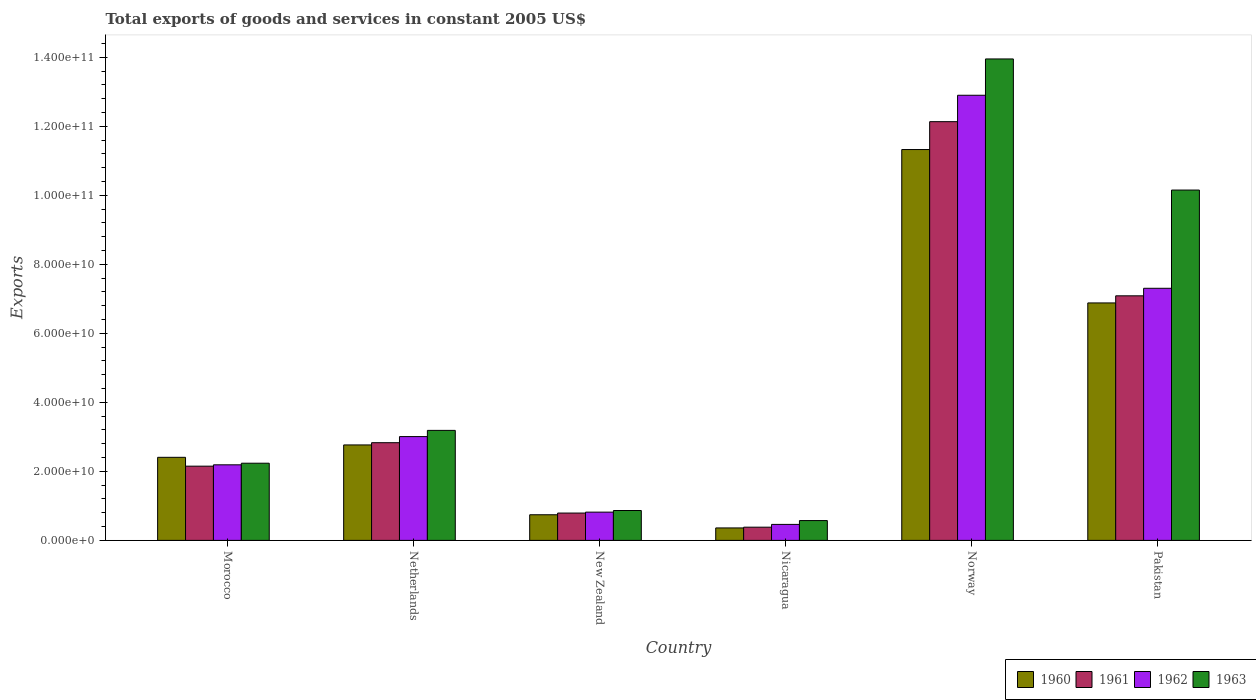How many groups of bars are there?
Your answer should be very brief. 6. Are the number of bars on each tick of the X-axis equal?
Keep it short and to the point. Yes. How many bars are there on the 3rd tick from the left?
Make the answer very short. 4. What is the label of the 1st group of bars from the left?
Keep it short and to the point. Morocco. In how many cases, is the number of bars for a given country not equal to the number of legend labels?
Offer a terse response. 0. What is the total exports of goods and services in 1961 in Norway?
Your answer should be very brief. 1.21e+11. Across all countries, what is the maximum total exports of goods and services in 1961?
Keep it short and to the point. 1.21e+11. Across all countries, what is the minimum total exports of goods and services in 1960?
Provide a succinct answer. 3.61e+09. In which country was the total exports of goods and services in 1963 maximum?
Give a very brief answer. Norway. In which country was the total exports of goods and services in 1963 minimum?
Offer a very short reply. Nicaragua. What is the total total exports of goods and services in 1962 in the graph?
Your answer should be compact. 2.67e+11. What is the difference between the total exports of goods and services in 1961 in New Zealand and that in Norway?
Make the answer very short. -1.13e+11. What is the difference between the total exports of goods and services in 1961 in Pakistan and the total exports of goods and services in 1960 in Norway?
Provide a short and direct response. -4.24e+1. What is the average total exports of goods and services in 1961 per country?
Keep it short and to the point. 4.23e+1. What is the difference between the total exports of goods and services of/in 1962 and total exports of goods and services of/in 1963 in Norway?
Provide a short and direct response. -1.05e+1. What is the ratio of the total exports of goods and services in 1962 in Morocco to that in Norway?
Offer a very short reply. 0.17. Is the total exports of goods and services in 1963 in Netherlands less than that in New Zealand?
Your answer should be very brief. No. Is the difference between the total exports of goods and services in 1962 in New Zealand and Pakistan greater than the difference between the total exports of goods and services in 1963 in New Zealand and Pakistan?
Keep it short and to the point. Yes. What is the difference between the highest and the second highest total exports of goods and services in 1962?
Give a very brief answer. 5.59e+1. What is the difference between the highest and the lowest total exports of goods and services in 1960?
Your answer should be very brief. 1.10e+11. In how many countries, is the total exports of goods and services in 1963 greater than the average total exports of goods and services in 1963 taken over all countries?
Offer a terse response. 2. Is the sum of the total exports of goods and services in 1960 in New Zealand and Norway greater than the maximum total exports of goods and services in 1963 across all countries?
Keep it short and to the point. No. Is it the case that in every country, the sum of the total exports of goods and services in 1960 and total exports of goods and services in 1962 is greater than the sum of total exports of goods and services in 1961 and total exports of goods and services in 1963?
Give a very brief answer. No. What does the 2nd bar from the left in Morocco represents?
Make the answer very short. 1961. How many bars are there?
Give a very brief answer. 24. Where does the legend appear in the graph?
Provide a short and direct response. Bottom right. What is the title of the graph?
Provide a succinct answer. Total exports of goods and services in constant 2005 US$. What is the label or title of the X-axis?
Make the answer very short. Country. What is the label or title of the Y-axis?
Your answer should be compact. Exports. What is the Exports in 1960 in Morocco?
Provide a short and direct response. 2.41e+1. What is the Exports in 1961 in Morocco?
Offer a terse response. 2.15e+1. What is the Exports in 1962 in Morocco?
Give a very brief answer. 2.19e+1. What is the Exports of 1963 in Morocco?
Your answer should be very brief. 2.24e+1. What is the Exports of 1960 in Netherlands?
Your response must be concise. 2.77e+1. What is the Exports in 1961 in Netherlands?
Provide a short and direct response. 2.83e+1. What is the Exports of 1962 in Netherlands?
Give a very brief answer. 3.01e+1. What is the Exports of 1963 in Netherlands?
Your answer should be compact. 3.19e+1. What is the Exports of 1960 in New Zealand?
Your answer should be very brief. 7.43e+09. What is the Exports of 1961 in New Zealand?
Keep it short and to the point. 7.92e+09. What is the Exports of 1962 in New Zealand?
Ensure brevity in your answer.  8.19e+09. What is the Exports in 1963 in New Zealand?
Your answer should be compact. 8.66e+09. What is the Exports in 1960 in Nicaragua?
Offer a very short reply. 3.61e+09. What is the Exports of 1961 in Nicaragua?
Make the answer very short. 3.83e+09. What is the Exports of 1962 in Nicaragua?
Ensure brevity in your answer.  4.64e+09. What is the Exports of 1963 in Nicaragua?
Your answer should be compact. 5.74e+09. What is the Exports in 1960 in Norway?
Provide a short and direct response. 1.13e+11. What is the Exports of 1961 in Norway?
Make the answer very short. 1.21e+11. What is the Exports of 1962 in Norway?
Ensure brevity in your answer.  1.29e+11. What is the Exports in 1963 in Norway?
Your answer should be very brief. 1.40e+11. What is the Exports in 1960 in Pakistan?
Keep it short and to the point. 6.88e+1. What is the Exports in 1961 in Pakistan?
Provide a succinct answer. 7.09e+1. What is the Exports in 1962 in Pakistan?
Your response must be concise. 7.31e+1. What is the Exports in 1963 in Pakistan?
Offer a terse response. 1.02e+11. Across all countries, what is the maximum Exports of 1960?
Provide a succinct answer. 1.13e+11. Across all countries, what is the maximum Exports of 1961?
Your answer should be compact. 1.21e+11. Across all countries, what is the maximum Exports of 1962?
Give a very brief answer. 1.29e+11. Across all countries, what is the maximum Exports of 1963?
Offer a terse response. 1.40e+11. Across all countries, what is the minimum Exports of 1960?
Offer a terse response. 3.61e+09. Across all countries, what is the minimum Exports in 1961?
Provide a succinct answer. 3.83e+09. Across all countries, what is the minimum Exports in 1962?
Provide a short and direct response. 4.64e+09. Across all countries, what is the minimum Exports in 1963?
Ensure brevity in your answer.  5.74e+09. What is the total Exports in 1960 in the graph?
Your answer should be very brief. 2.45e+11. What is the total Exports of 1961 in the graph?
Provide a succinct answer. 2.54e+11. What is the total Exports in 1962 in the graph?
Keep it short and to the point. 2.67e+11. What is the total Exports of 1963 in the graph?
Offer a very short reply. 3.10e+11. What is the difference between the Exports in 1960 in Morocco and that in Netherlands?
Provide a succinct answer. -3.59e+09. What is the difference between the Exports in 1961 in Morocco and that in Netherlands?
Offer a terse response. -6.80e+09. What is the difference between the Exports of 1962 in Morocco and that in Netherlands?
Offer a very short reply. -8.18e+09. What is the difference between the Exports in 1963 in Morocco and that in Netherlands?
Ensure brevity in your answer.  -9.51e+09. What is the difference between the Exports of 1960 in Morocco and that in New Zealand?
Your response must be concise. 1.66e+1. What is the difference between the Exports of 1961 in Morocco and that in New Zealand?
Offer a terse response. 1.36e+1. What is the difference between the Exports of 1962 in Morocco and that in New Zealand?
Your answer should be compact. 1.37e+1. What is the difference between the Exports of 1963 in Morocco and that in New Zealand?
Make the answer very short. 1.37e+1. What is the difference between the Exports in 1960 in Morocco and that in Nicaragua?
Keep it short and to the point. 2.05e+1. What is the difference between the Exports of 1961 in Morocco and that in Nicaragua?
Keep it short and to the point. 1.77e+1. What is the difference between the Exports in 1962 in Morocco and that in Nicaragua?
Your answer should be compact. 1.73e+1. What is the difference between the Exports of 1963 in Morocco and that in Nicaragua?
Make the answer very short. 1.66e+1. What is the difference between the Exports in 1960 in Morocco and that in Norway?
Offer a terse response. -8.92e+1. What is the difference between the Exports in 1961 in Morocco and that in Norway?
Give a very brief answer. -9.98e+1. What is the difference between the Exports in 1962 in Morocco and that in Norway?
Provide a succinct answer. -1.07e+11. What is the difference between the Exports in 1963 in Morocco and that in Norway?
Your answer should be compact. -1.17e+11. What is the difference between the Exports in 1960 in Morocco and that in Pakistan?
Your answer should be compact. -4.47e+1. What is the difference between the Exports in 1961 in Morocco and that in Pakistan?
Make the answer very short. -4.94e+1. What is the difference between the Exports of 1962 in Morocco and that in Pakistan?
Offer a terse response. -5.12e+1. What is the difference between the Exports of 1963 in Morocco and that in Pakistan?
Offer a terse response. -7.92e+1. What is the difference between the Exports of 1960 in Netherlands and that in New Zealand?
Your answer should be compact. 2.02e+1. What is the difference between the Exports of 1961 in Netherlands and that in New Zealand?
Give a very brief answer. 2.04e+1. What is the difference between the Exports in 1962 in Netherlands and that in New Zealand?
Give a very brief answer. 2.19e+1. What is the difference between the Exports of 1963 in Netherlands and that in New Zealand?
Give a very brief answer. 2.32e+1. What is the difference between the Exports in 1960 in Netherlands and that in Nicaragua?
Make the answer very short. 2.41e+1. What is the difference between the Exports of 1961 in Netherlands and that in Nicaragua?
Offer a terse response. 2.45e+1. What is the difference between the Exports of 1962 in Netherlands and that in Nicaragua?
Your answer should be compact. 2.54e+1. What is the difference between the Exports of 1963 in Netherlands and that in Nicaragua?
Offer a very short reply. 2.61e+1. What is the difference between the Exports of 1960 in Netherlands and that in Norway?
Make the answer very short. -8.56e+1. What is the difference between the Exports in 1961 in Netherlands and that in Norway?
Ensure brevity in your answer.  -9.30e+1. What is the difference between the Exports in 1962 in Netherlands and that in Norway?
Provide a succinct answer. -9.89e+1. What is the difference between the Exports in 1963 in Netherlands and that in Norway?
Keep it short and to the point. -1.08e+11. What is the difference between the Exports of 1960 in Netherlands and that in Pakistan?
Offer a very short reply. -4.11e+1. What is the difference between the Exports of 1961 in Netherlands and that in Pakistan?
Your answer should be very brief. -4.26e+1. What is the difference between the Exports in 1962 in Netherlands and that in Pakistan?
Make the answer very short. -4.30e+1. What is the difference between the Exports in 1963 in Netherlands and that in Pakistan?
Provide a short and direct response. -6.96e+1. What is the difference between the Exports in 1960 in New Zealand and that in Nicaragua?
Offer a terse response. 3.82e+09. What is the difference between the Exports of 1961 in New Zealand and that in Nicaragua?
Your answer should be very brief. 4.10e+09. What is the difference between the Exports in 1962 in New Zealand and that in Nicaragua?
Keep it short and to the point. 3.55e+09. What is the difference between the Exports in 1963 in New Zealand and that in Nicaragua?
Give a very brief answer. 2.92e+09. What is the difference between the Exports in 1960 in New Zealand and that in Norway?
Make the answer very short. -1.06e+11. What is the difference between the Exports of 1961 in New Zealand and that in Norway?
Offer a very short reply. -1.13e+11. What is the difference between the Exports of 1962 in New Zealand and that in Norway?
Your answer should be very brief. -1.21e+11. What is the difference between the Exports of 1963 in New Zealand and that in Norway?
Provide a short and direct response. -1.31e+11. What is the difference between the Exports in 1960 in New Zealand and that in Pakistan?
Offer a very short reply. -6.14e+1. What is the difference between the Exports in 1961 in New Zealand and that in Pakistan?
Keep it short and to the point. -6.29e+1. What is the difference between the Exports of 1962 in New Zealand and that in Pakistan?
Offer a very short reply. -6.49e+1. What is the difference between the Exports in 1963 in New Zealand and that in Pakistan?
Provide a succinct answer. -9.29e+1. What is the difference between the Exports of 1960 in Nicaragua and that in Norway?
Ensure brevity in your answer.  -1.10e+11. What is the difference between the Exports of 1961 in Nicaragua and that in Norway?
Your answer should be very brief. -1.18e+11. What is the difference between the Exports of 1962 in Nicaragua and that in Norway?
Your response must be concise. -1.24e+11. What is the difference between the Exports of 1963 in Nicaragua and that in Norway?
Offer a terse response. -1.34e+11. What is the difference between the Exports in 1960 in Nicaragua and that in Pakistan?
Offer a very short reply. -6.52e+1. What is the difference between the Exports in 1961 in Nicaragua and that in Pakistan?
Make the answer very short. -6.70e+1. What is the difference between the Exports of 1962 in Nicaragua and that in Pakistan?
Provide a short and direct response. -6.84e+1. What is the difference between the Exports of 1963 in Nicaragua and that in Pakistan?
Offer a very short reply. -9.58e+1. What is the difference between the Exports in 1960 in Norway and that in Pakistan?
Offer a very short reply. 4.44e+1. What is the difference between the Exports in 1961 in Norway and that in Pakistan?
Offer a terse response. 5.05e+1. What is the difference between the Exports of 1962 in Norway and that in Pakistan?
Your response must be concise. 5.59e+1. What is the difference between the Exports in 1963 in Norway and that in Pakistan?
Your answer should be very brief. 3.80e+1. What is the difference between the Exports of 1960 in Morocco and the Exports of 1961 in Netherlands?
Provide a short and direct response. -4.24e+09. What is the difference between the Exports of 1960 in Morocco and the Exports of 1962 in Netherlands?
Offer a very short reply. -6.01e+09. What is the difference between the Exports in 1960 in Morocco and the Exports in 1963 in Netherlands?
Make the answer very short. -7.80e+09. What is the difference between the Exports in 1961 in Morocco and the Exports in 1962 in Netherlands?
Your answer should be very brief. -8.57e+09. What is the difference between the Exports in 1961 in Morocco and the Exports in 1963 in Netherlands?
Offer a very short reply. -1.04e+1. What is the difference between the Exports of 1962 in Morocco and the Exports of 1963 in Netherlands?
Your response must be concise. -9.98e+09. What is the difference between the Exports in 1960 in Morocco and the Exports in 1961 in New Zealand?
Provide a succinct answer. 1.61e+1. What is the difference between the Exports in 1960 in Morocco and the Exports in 1962 in New Zealand?
Your response must be concise. 1.59e+1. What is the difference between the Exports in 1960 in Morocco and the Exports in 1963 in New Zealand?
Your response must be concise. 1.54e+1. What is the difference between the Exports in 1961 in Morocco and the Exports in 1962 in New Zealand?
Offer a very short reply. 1.33e+1. What is the difference between the Exports in 1961 in Morocco and the Exports in 1963 in New Zealand?
Provide a short and direct response. 1.29e+1. What is the difference between the Exports in 1962 in Morocco and the Exports in 1963 in New Zealand?
Your response must be concise. 1.32e+1. What is the difference between the Exports in 1960 in Morocco and the Exports in 1961 in Nicaragua?
Your answer should be very brief. 2.02e+1. What is the difference between the Exports of 1960 in Morocco and the Exports of 1962 in Nicaragua?
Your answer should be compact. 1.94e+1. What is the difference between the Exports in 1960 in Morocco and the Exports in 1963 in Nicaragua?
Give a very brief answer. 1.83e+1. What is the difference between the Exports of 1961 in Morocco and the Exports of 1962 in Nicaragua?
Provide a succinct answer. 1.69e+1. What is the difference between the Exports in 1961 in Morocco and the Exports in 1963 in Nicaragua?
Offer a very short reply. 1.58e+1. What is the difference between the Exports in 1962 in Morocco and the Exports in 1963 in Nicaragua?
Offer a terse response. 1.62e+1. What is the difference between the Exports in 1960 in Morocco and the Exports in 1961 in Norway?
Provide a short and direct response. -9.73e+1. What is the difference between the Exports of 1960 in Morocco and the Exports of 1962 in Norway?
Provide a short and direct response. -1.05e+11. What is the difference between the Exports of 1960 in Morocco and the Exports of 1963 in Norway?
Give a very brief answer. -1.15e+11. What is the difference between the Exports of 1961 in Morocco and the Exports of 1962 in Norway?
Offer a very short reply. -1.07e+11. What is the difference between the Exports of 1961 in Morocco and the Exports of 1963 in Norway?
Offer a terse response. -1.18e+11. What is the difference between the Exports in 1962 in Morocco and the Exports in 1963 in Norway?
Your answer should be very brief. -1.18e+11. What is the difference between the Exports in 1960 in Morocco and the Exports in 1961 in Pakistan?
Ensure brevity in your answer.  -4.68e+1. What is the difference between the Exports of 1960 in Morocco and the Exports of 1962 in Pakistan?
Provide a short and direct response. -4.90e+1. What is the difference between the Exports of 1960 in Morocco and the Exports of 1963 in Pakistan?
Give a very brief answer. -7.74e+1. What is the difference between the Exports in 1961 in Morocco and the Exports in 1962 in Pakistan?
Offer a very short reply. -5.15e+1. What is the difference between the Exports of 1961 in Morocco and the Exports of 1963 in Pakistan?
Give a very brief answer. -8.00e+1. What is the difference between the Exports in 1962 in Morocco and the Exports in 1963 in Pakistan?
Give a very brief answer. -7.96e+1. What is the difference between the Exports of 1960 in Netherlands and the Exports of 1961 in New Zealand?
Offer a terse response. 1.97e+1. What is the difference between the Exports in 1960 in Netherlands and the Exports in 1962 in New Zealand?
Keep it short and to the point. 1.95e+1. What is the difference between the Exports of 1960 in Netherlands and the Exports of 1963 in New Zealand?
Keep it short and to the point. 1.90e+1. What is the difference between the Exports in 1961 in Netherlands and the Exports in 1962 in New Zealand?
Provide a short and direct response. 2.01e+1. What is the difference between the Exports in 1961 in Netherlands and the Exports in 1963 in New Zealand?
Your answer should be very brief. 1.97e+1. What is the difference between the Exports in 1962 in Netherlands and the Exports in 1963 in New Zealand?
Provide a succinct answer. 2.14e+1. What is the difference between the Exports in 1960 in Netherlands and the Exports in 1961 in Nicaragua?
Your answer should be very brief. 2.38e+1. What is the difference between the Exports in 1960 in Netherlands and the Exports in 1962 in Nicaragua?
Make the answer very short. 2.30e+1. What is the difference between the Exports in 1960 in Netherlands and the Exports in 1963 in Nicaragua?
Give a very brief answer. 2.19e+1. What is the difference between the Exports in 1961 in Netherlands and the Exports in 1962 in Nicaragua?
Provide a short and direct response. 2.37e+1. What is the difference between the Exports of 1961 in Netherlands and the Exports of 1963 in Nicaragua?
Your response must be concise. 2.26e+1. What is the difference between the Exports of 1962 in Netherlands and the Exports of 1963 in Nicaragua?
Make the answer very short. 2.43e+1. What is the difference between the Exports in 1960 in Netherlands and the Exports in 1961 in Norway?
Make the answer very short. -9.37e+1. What is the difference between the Exports of 1960 in Netherlands and the Exports of 1962 in Norway?
Give a very brief answer. -1.01e+11. What is the difference between the Exports of 1960 in Netherlands and the Exports of 1963 in Norway?
Your response must be concise. -1.12e+11. What is the difference between the Exports of 1961 in Netherlands and the Exports of 1962 in Norway?
Offer a terse response. -1.01e+11. What is the difference between the Exports of 1961 in Netherlands and the Exports of 1963 in Norway?
Provide a succinct answer. -1.11e+11. What is the difference between the Exports of 1962 in Netherlands and the Exports of 1963 in Norway?
Provide a short and direct response. -1.09e+11. What is the difference between the Exports in 1960 in Netherlands and the Exports in 1961 in Pakistan?
Give a very brief answer. -4.32e+1. What is the difference between the Exports of 1960 in Netherlands and the Exports of 1962 in Pakistan?
Your response must be concise. -4.54e+1. What is the difference between the Exports in 1960 in Netherlands and the Exports in 1963 in Pakistan?
Ensure brevity in your answer.  -7.39e+1. What is the difference between the Exports in 1961 in Netherlands and the Exports in 1962 in Pakistan?
Ensure brevity in your answer.  -4.47e+1. What is the difference between the Exports of 1961 in Netherlands and the Exports of 1963 in Pakistan?
Make the answer very short. -7.32e+1. What is the difference between the Exports in 1962 in Netherlands and the Exports in 1963 in Pakistan?
Ensure brevity in your answer.  -7.14e+1. What is the difference between the Exports in 1960 in New Zealand and the Exports in 1961 in Nicaragua?
Give a very brief answer. 3.60e+09. What is the difference between the Exports of 1960 in New Zealand and the Exports of 1962 in Nicaragua?
Ensure brevity in your answer.  2.79e+09. What is the difference between the Exports of 1960 in New Zealand and the Exports of 1963 in Nicaragua?
Give a very brief answer. 1.68e+09. What is the difference between the Exports of 1961 in New Zealand and the Exports of 1962 in Nicaragua?
Give a very brief answer. 3.29e+09. What is the difference between the Exports of 1961 in New Zealand and the Exports of 1963 in Nicaragua?
Provide a succinct answer. 2.18e+09. What is the difference between the Exports in 1962 in New Zealand and the Exports in 1963 in Nicaragua?
Ensure brevity in your answer.  2.45e+09. What is the difference between the Exports of 1960 in New Zealand and the Exports of 1961 in Norway?
Offer a very short reply. -1.14e+11. What is the difference between the Exports of 1960 in New Zealand and the Exports of 1962 in Norway?
Ensure brevity in your answer.  -1.22e+11. What is the difference between the Exports of 1960 in New Zealand and the Exports of 1963 in Norway?
Keep it short and to the point. -1.32e+11. What is the difference between the Exports in 1961 in New Zealand and the Exports in 1962 in Norway?
Provide a succinct answer. -1.21e+11. What is the difference between the Exports of 1961 in New Zealand and the Exports of 1963 in Norway?
Keep it short and to the point. -1.32e+11. What is the difference between the Exports in 1962 in New Zealand and the Exports in 1963 in Norway?
Ensure brevity in your answer.  -1.31e+11. What is the difference between the Exports of 1960 in New Zealand and the Exports of 1961 in Pakistan?
Your answer should be very brief. -6.34e+1. What is the difference between the Exports of 1960 in New Zealand and the Exports of 1962 in Pakistan?
Your answer should be very brief. -6.56e+1. What is the difference between the Exports of 1960 in New Zealand and the Exports of 1963 in Pakistan?
Ensure brevity in your answer.  -9.41e+1. What is the difference between the Exports of 1961 in New Zealand and the Exports of 1962 in Pakistan?
Your answer should be very brief. -6.51e+1. What is the difference between the Exports of 1961 in New Zealand and the Exports of 1963 in Pakistan?
Offer a terse response. -9.36e+1. What is the difference between the Exports in 1962 in New Zealand and the Exports in 1963 in Pakistan?
Your answer should be very brief. -9.33e+1. What is the difference between the Exports in 1960 in Nicaragua and the Exports in 1961 in Norway?
Offer a terse response. -1.18e+11. What is the difference between the Exports of 1960 in Nicaragua and the Exports of 1962 in Norway?
Make the answer very short. -1.25e+11. What is the difference between the Exports of 1960 in Nicaragua and the Exports of 1963 in Norway?
Keep it short and to the point. -1.36e+11. What is the difference between the Exports of 1961 in Nicaragua and the Exports of 1962 in Norway?
Your answer should be compact. -1.25e+11. What is the difference between the Exports of 1961 in Nicaragua and the Exports of 1963 in Norway?
Your answer should be compact. -1.36e+11. What is the difference between the Exports of 1962 in Nicaragua and the Exports of 1963 in Norway?
Offer a terse response. -1.35e+11. What is the difference between the Exports in 1960 in Nicaragua and the Exports in 1961 in Pakistan?
Your answer should be compact. -6.73e+1. What is the difference between the Exports of 1960 in Nicaragua and the Exports of 1962 in Pakistan?
Offer a terse response. -6.94e+1. What is the difference between the Exports in 1960 in Nicaragua and the Exports in 1963 in Pakistan?
Your response must be concise. -9.79e+1. What is the difference between the Exports in 1961 in Nicaragua and the Exports in 1962 in Pakistan?
Provide a short and direct response. -6.92e+1. What is the difference between the Exports of 1961 in Nicaragua and the Exports of 1963 in Pakistan?
Make the answer very short. -9.77e+1. What is the difference between the Exports in 1962 in Nicaragua and the Exports in 1963 in Pakistan?
Offer a terse response. -9.69e+1. What is the difference between the Exports in 1960 in Norway and the Exports in 1961 in Pakistan?
Ensure brevity in your answer.  4.24e+1. What is the difference between the Exports in 1960 in Norway and the Exports in 1962 in Pakistan?
Provide a short and direct response. 4.02e+1. What is the difference between the Exports of 1960 in Norway and the Exports of 1963 in Pakistan?
Provide a short and direct response. 1.17e+1. What is the difference between the Exports in 1961 in Norway and the Exports in 1962 in Pakistan?
Your response must be concise. 4.83e+1. What is the difference between the Exports of 1961 in Norway and the Exports of 1963 in Pakistan?
Offer a terse response. 1.98e+1. What is the difference between the Exports of 1962 in Norway and the Exports of 1963 in Pakistan?
Make the answer very short. 2.75e+1. What is the average Exports of 1960 per country?
Your answer should be compact. 4.08e+1. What is the average Exports in 1961 per country?
Provide a short and direct response. 4.23e+1. What is the average Exports of 1962 per country?
Keep it short and to the point. 4.45e+1. What is the average Exports in 1963 per country?
Ensure brevity in your answer.  5.16e+1. What is the difference between the Exports in 1960 and Exports in 1961 in Morocco?
Ensure brevity in your answer.  2.56e+09. What is the difference between the Exports in 1960 and Exports in 1962 in Morocco?
Give a very brief answer. 2.17e+09. What is the difference between the Exports in 1960 and Exports in 1963 in Morocco?
Make the answer very short. 1.71e+09. What is the difference between the Exports in 1961 and Exports in 1962 in Morocco?
Your answer should be compact. -3.89e+08. What is the difference between the Exports of 1961 and Exports of 1963 in Morocco?
Your answer should be very brief. -8.54e+08. What is the difference between the Exports of 1962 and Exports of 1963 in Morocco?
Ensure brevity in your answer.  -4.65e+08. What is the difference between the Exports in 1960 and Exports in 1961 in Netherlands?
Your response must be concise. -6.49e+08. What is the difference between the Exports of 1960 and Exports of 1962 in Netherlands?
Provide a short and direct response. -2.42e+09. What is the difference between the Exports of 1960 and Exports of 1963 in Netherlands?
Make the answer very short. -4.21e+09. What is the difference between the Exports in 1961 and Exports in 1962 in Netherlands?
Offer a terse response. -1.77e+09. What is the difference between the Exports of 1961 and Exports of 1963 in Netherlands?
Keep it short and to the point. -3.57e+09. What is the difference between the Exports in 1962 and Exports in 1963 in Netherlands?
Provide a succinct answer. -1.80e+09. What is the difference between the Exports of 1960 and Exports of 1961 in New Zealand?
Your answer should be very brief. -4.96e+08. What is the difference between the Exports of 1960 and Exports of 1962 in New Zealand?
Offer a very short reply. -7.63e+08. What is the difference between the Exports in 1960 and Exports in 1963 in New Zealand?
Provide a short and direct response. -1.23e+09. What is the difference between the Exports of 1961 and Exports of 1962 in New Zealand?
Your answer should be compact. -2.67e+08. What is the difference between the Exports in 1961 and Exports in 1963 in New Zealand?
Provide a short and direct response. -7.36e+08. What is the difference between the Exports in 1962 and Exports in 1963 in New Zealand?
Keep it short and to the point. -4.69e+08. What is the difference between the Exports in 1960 and Exports in 1961 in Nicaragua?
Your answer should be compact. -2.16e+08. What is the difference between the Exports of 1960 and Exports of 1962 in Nicaragua?
Offer a terse response. -1.02e+09. What is the difference between the Exports of 1960 and Exports of 1963 in Nicaragua?
Keep it short and to the point. -2.13e+09. What is the difference between the Exports of 1961 and Exports of 1962 in Nicaragua?
Offer a terse response. -8.09e+08. What is the difference between the Exports of 1961 and Exports of 1963 in Nicaragua?
Give a very brief answer. -1.92e+09. What is the difference between the Exports in 1962 and Exports in 1963 in Nicaragua?
Give a very brief answer. -1.11e+09. What is the difference between the Exports of 1960 and Exports of 1961 in Norway?
Make the answer very short. -8.08e+09. What is the difference between the Exports of 1960 and Exports of 1962 in Norway?
Your answer should be compact. -1.57e+1. What is the difference between the Exports in 1960 and Exports in 1963 in Norway?
Offer a very short reply. -2.63e+1. What is the difference between the Exports in 1961 and Exports in 1962 in Norway?
Provide a short and direct response. -7.65e+09. What is the difference between the Exports in 1961 and Exports in 1963 in Norway?
Make the answer very short. -1.82e+1. What is the difference between the Exports of 1962 and Exports of 1963 in Norway?
Offer a terse response. -1.05e+1. What is the difference between the Exports in 1960 and Exports in 1961 in Pakistan?
Make the answer very short. -2.06e+09. What is the difference between the Exports of 1960 and Exports of 1962 in Pakistan?
Make the answer very short. -4.24e+09. What is the difference between the Exports in 1960 and Exports in 1963 in Pakistan?
Keep it short and to the point. -3.27e+1. What is the difference between the Exports in 1961 and Exports in 1962 in Pakistan?
Ensure brevity in your answer.  -2.18e+09. What is the difference between the Exports in 1961 and Exports in 1963 in Pakistan?
Offer a terse response. -3.06e+1. What is the difference between the Exports in 1962 and Exports in 1963 in Pakistan?
Offer a terse response. -2.85e+1. What is the ratio of the Exports of 1960 in Morocco to that in Netherlands?
Your answer should be very brief. 0.87. What is the ratio of the Exports of 1961 in Morocco to that in Netherlands?
Keep it short and to the point. 0.76. What is the ratio of the Exports in 1962 in Morocco to that in Netherlands?
Make the answer very short. 0.73. What is the ratio of the Exports in 1963 in Morocco to that in Netherlands?
Your answer should be compact. 0.7. What is the ratio of the Exports in 1960 in Morocco to that in New Zealand?
Your answer should be compact. 3.24. What is the ratio of the Exports of 1961 in Morocco to that in New Zealand?
Offer a very short reply. 2.71. What is the ratio of the Exports of 1962 in Morocco to that in New Zealand?
Your answer should be compact. 2.67. What is the ratio of the Exports of 1963 in Morocco to that in New Zealand?
Ensure brevity in your answer.  2.58. What is the ratio of the Exports of 1960 in Morocco to that in Nicaragua?
Your response must be concise. 6.67. What is the ratio of the Exports in 1961 in Morocco to that in Nicaragua?
Make the answer very short. 5.62. What is the ratio of the Exports of 1962 in Morocco to that in Nicaragua?
Provide a succinct answer. 4.72. What is the ratio of the Exports of 1963 in Morocco to that in Nicaragua?
Offer a terse response. 3.89. What is the ratio of the Exports in 1960 in Morocco to that in Norway?
Keep it short and to the point. 0.21. What is the ratio of the Exports in 1961 in Morocco to that in Norway?
Your answer should be very brief. 0.18. What is the ratio of the Exports in 1962 in Morocco to that in Norway?
Provide a succinct answer. 0.17. What is the ratio of the Exports in 1963 in Morocco to that in Norway?
Offer a terse response. 0.16. What is the ratio of the Exports in 1960 in Morocco to that in Pakistan?
Ensure brevity in your answer.  0.35. What is the ratio of the Exports of 1961 in Morocco to that in Pakistan?
Keep it short and to the point. 0.3. What is the ratio of the Exports of 1962 in Morocco to that in Pakistan?
Your response must be concise. 0.3. What is the ratio of the Exports in 1963 in Morocco to that in Pakistan?
Your answer should be very brief. 0.22. What is the ratio of the Exports of 1960 in Netherlands to that in New Zealand?
Provide a succinct answer. 3.72. What is the ratio of the Exports in 1961 in Netherlands to that in New Zealand?
Give a very brief answer. 3.57. What is the ratio of the Exports in 1962 in Netherlands to that in New Zealand?
Offer a terse response. 3.67. What is the ratio of the Exports of 1963 in Netherlands to that in New Zealand?
Give a very brief answer. 3.68. What is the ratio of the Exports in 1960 in Netherlands to that in Nicaragua?
Ensure brevity in your answer.  7.66. What is the ratio of the Exports of 1961 in Netherlands to that in Nicaragua?
Your response must be concise. 7.4. What is the ratio of the Exports in 1962 in Netherlands to that in Nicaragua?
Offer a terse response. 6.49. What is the ratio of the Exports of 1963 in Netherlands to that in Nicaragua?
Keep it short and to the point. 5.55. What is the ratio of the Exports of 1960 in Netherlands to that in Norway?
Provide a short and direct response. 0.24. What is the ratio of the Exports in 1961 in Netherlands to that in Norway?
Your answer should be very brief. 0.23. What is the ratio of the Exports of 1962 in Netherlands to that in Norway?
Provide a short and direct response. 0.23. What is the ratio of the Exports in 1963 in Netherlands to that in Norway?
Provide a succinct answer. 0.23. What is the ratio of the Exports of 1960 in Netherlands to that in Pakistan?
Provide a short and direct response. 0.4. What is the ratio of the Exports in 1961 in Netherlands to that in Pakistan?
Make the answer very short. 0.4. What is the ratio of the Exports in 1962 in Netherlands to that in Pakistan?
Your answer should be compact. 0.41. What is the ratio of the Exports of 1963 in Netherlands to that in Pakistan?
Your answer should be compact. 0.31. What is the ratio of the Exports in 1960 in New Zealand to that in Nicaragua?
Keep it short and to the point. 2.06. What is the ratio of the Exports of 1961 in New Zealand to that in Nicaragua?
Your answer should be very brief. 2.07. What is the ratio of the Exports in 1962 in New Zealand to that in Nicaragua?
Provide a succinct answer. 1.77. What is the ratio of the Exports in 1963 in New Zealand to that in Nicaragua?
Give a very brief answer. 1.51. What is the ratio of the Exports of 1960 in New Zealand to that in Norway?
Ensure brevity in your answer.  0.07. What is the ratio of the Exports of 1961 in New Zealand to that in Norway?
Offer a very short reply. 0.07. What is the ratio of the Exports in 1962 in New Zealand to that in Norway?
Your answer should be compact. 0.06. What is the ratio of the Exports of 1963 in New Zealand to that in Norway?
Your response must be concise. 0.06. What is the ratio of the Exports in 1960 in New Zealand to that in Pakistan?
Make the answer very short. 0.11. What is the ratio of the Exports in 1961 in New Zealand to that in Pakistan?
Make the answer very short. 0.11. What is the ratio of the Exports of 1962 in New Zealand to that in Pakistan?
Keep it short and to the point. 0.11. What is the ratio of the Exports of 1963 in New Zealand to that in Pakistan?
Offer a terse response. 0.09. What is the ratio of the Exports in 1960 in Nicaragua to that in Norway?
Make the answer very short. 0.03. What is the ratio of the Exports of 1961 in Nicaragua to that in Norway?
Provide a short and direct response. 0.03. What is the ratio of the Exports of 1962 in Nicaragua to that in Norway?
Make the answer very short. 0.04. What is the ratio of the Exports in 1963 in Nicaragua to that in Norway?
Offer a terse response. 0.04. What is the ratio of the Exports of 1960 in Nicaragua to that in Pakistan?
Offer a very short reply. 0.05. What is the ratio of the Exports in 1961 in Nicaragua to that in Pakistan?
Give a very brief answer. 0.05. What is the ratio of the Exports of 1962 in Nicaragua to that in Pakistan?
Keep it short and to the point. 0.06. What is the ratio of the Exports in 1963 in Nicaragua to that in Pakistan?
Your answer should be very brief. 0.06. What is the ratio of the Exports of 1960 in Norway to that in Pakistan?
Your response must be concise. 1.65. What is the ratio of the Exports in 1961 in Norway to that in Pakistan?
Ensure brevity in your answer.  1.71. What is the ratio of the Exports of 1962 in Norway to that in Pakistan?
Make the answer very short. 1.77. What is the ratio of the Exports in 1963 in Norway to that in Pakistan?
Your response must be concise. 1.37. What is the difference between the highest and the second highest Exports in 1960?
Provide a short and direct response. 4.44e+1. What is the difference between the highest and the second highest Exports in 1961?
Your response must be concise. 5.05e+1. What is the difference between the highest and the second highest Exports in 1962?
Offer a terse response. 5.59e+1. What is the difference between the highest and the second highest Exports in 1963?
Give a very brief answer. 3.80e+1. What is the difference between the highest and the lowest Exports of 1960?
Provide a short and direct response. 1.10e+11. What is the difference between the highest and the lowest Exports of 1961?
Give a very brief answer. 1.18e+11. What is the difference between the highest and the lowest Exports of 1962?
Keep it short and to the point. 1.24e+11. What is the difference between the highest and the lowest Exports in 1963?
Your response must be concise. 1.34e+11. 